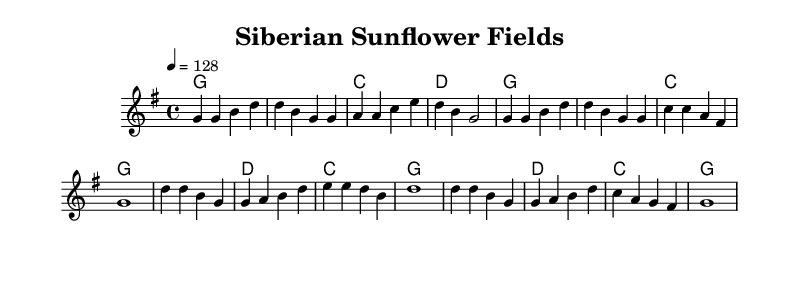What is the key signature of this music? The key signature shown is G major, which has one sharp (F#).
Answer: G major What is the time signature of this music? The time signature displayed at the beginning is 4/4, indicating four beats in a measure.
Answer: 4/4 What is the tempo marking of this piece? The tempo marking indicates a speed of 128 beats per minute, which is considered fast and upbeat for a country rock song.
Answer: 128 How many measures are in the verse? The verse section has four measures based on the grouping of notes and bar lines shown.
Answer: Four measures What is the first chord of the chorus? The first chord indicated in the chorus is G major, as shown at the beginning of that section on the staff.
Answer: G What is the melodic pattern in the first line of the verse? The melodic pattern in the first line starts with two G notes, followed by B and D, outlining a common motif in country rock melodies.
Answer: Starts with G What type of harmony is primarily used in this piece? The chord structure reveals a mixture of major chords, typically found in upbeat country rock music, and emphasizes the major tonality.
Answer: Major chords 